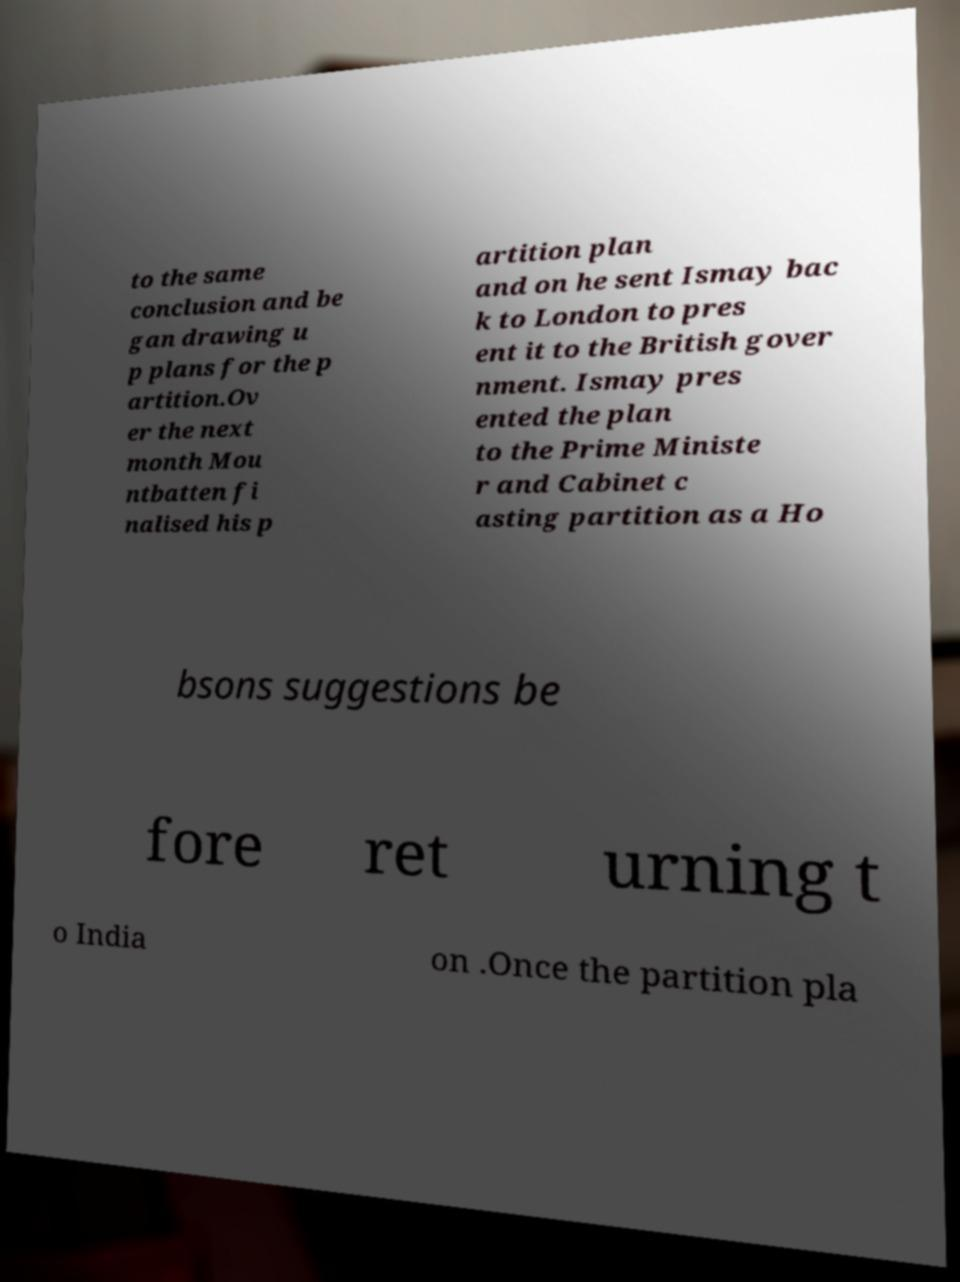I need the written content from this picture converted into text. Can you do that? to the same conclusion and be gan drawing u p plans for the p artition.Ov er the next month Mou ntbatten fi nalised his p artition plan and on he sent Ismay bac k to London to pres ent it to the British gover nment. Ismay pres ented the plan to the Prime Ministe r and Cabinet c asting partition as a Ho bsons suggestions be fore ret urning t o India on .Once the partition pla 